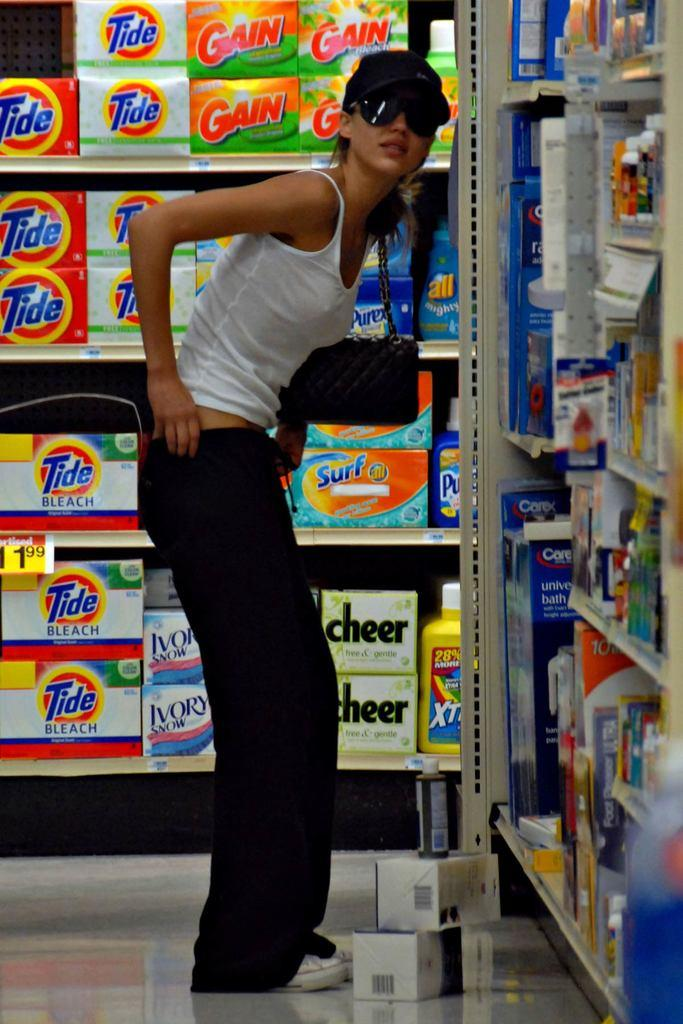<image>
Create a compact narrative representing the image presented. A woman shopping in the aisle with Tide, Gain, Surf, and Cheer detergents. 